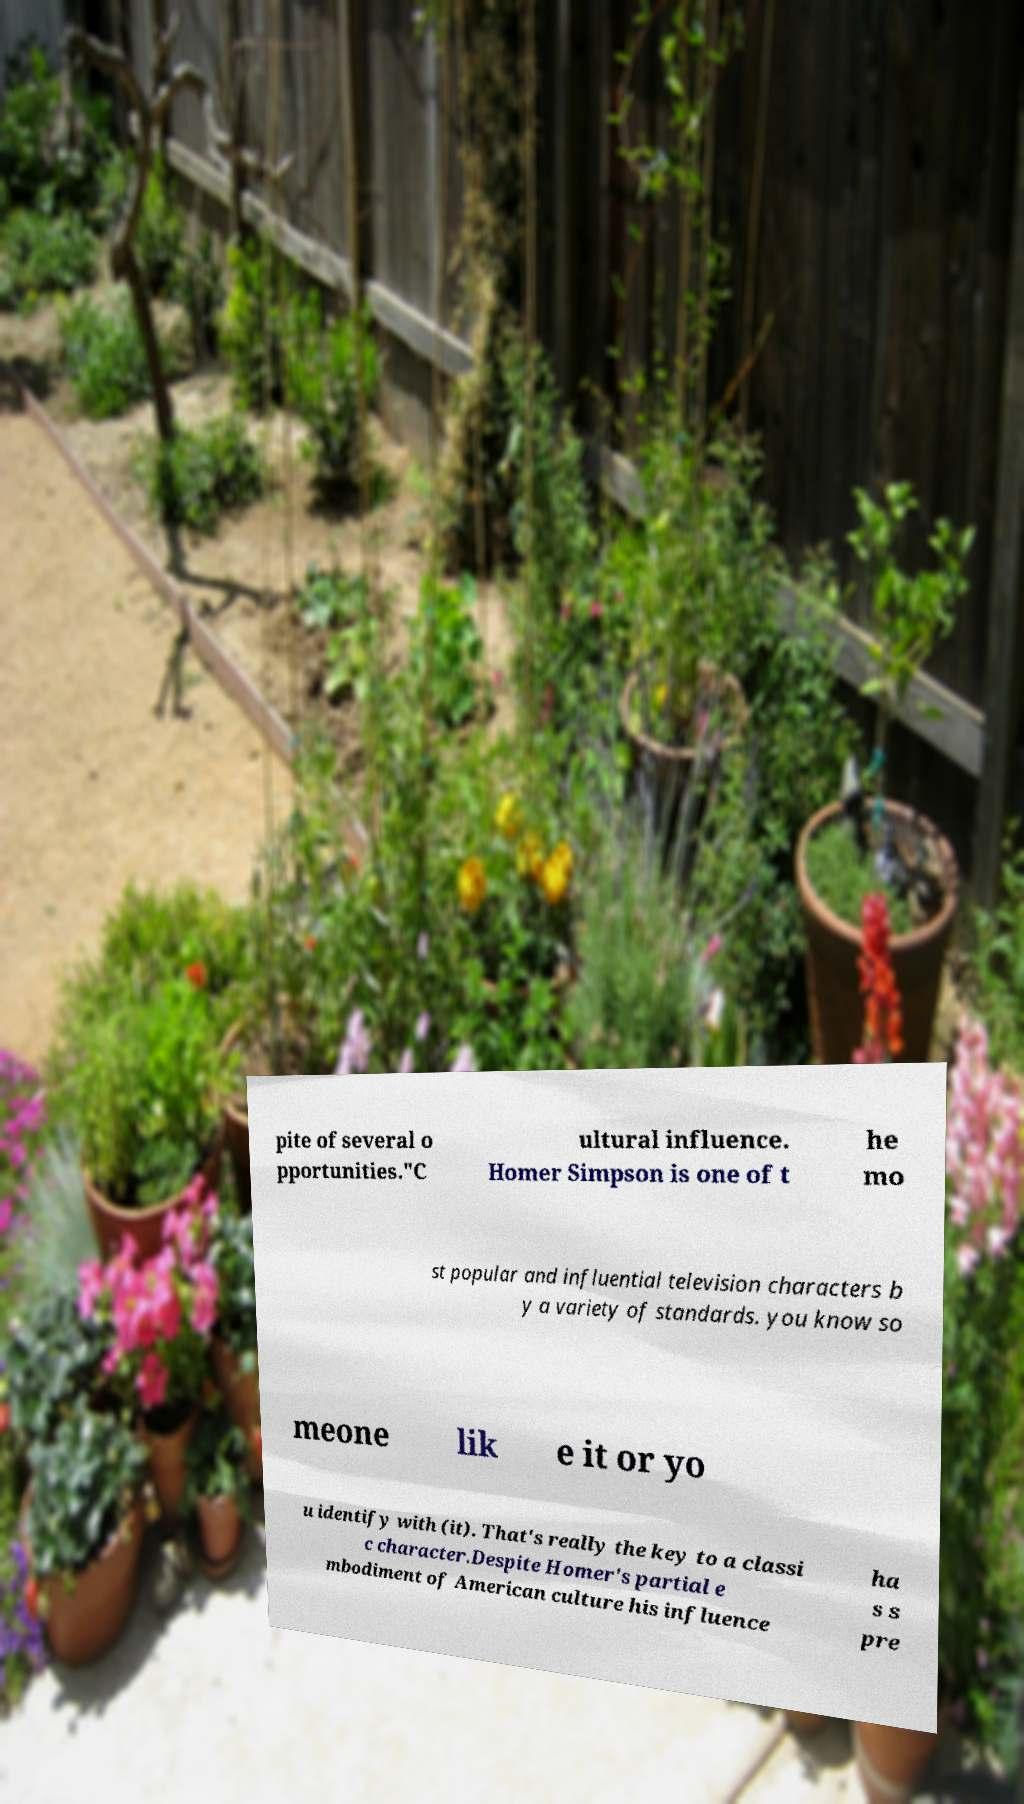Please identify and transcribe the text found in this image. pite of several o pportunities."C ultural influence. Homer Simpson is one of t he mo st popular and influential television characters b y a variety of standards. you know so meone lik e it or yo u identify with (it). That's really the key to a classi c character.Despite Homer's partial e mbodiment of American culture his influence ha s s pre 